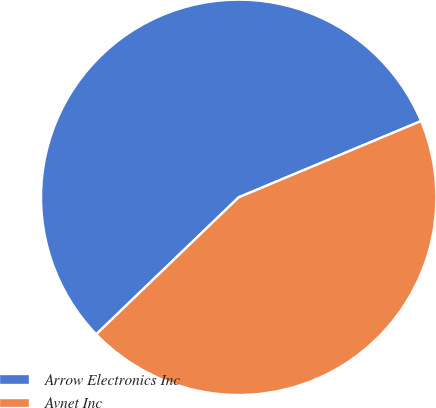Convert chart to OTSL. <chart><loc_0><loc_0><loc_500><loc_500><pie_chart><fcel>Arrow Electronics Inc<fcel>Avnet Inc<nl><fcel>55.88%<fcel>44.12%<nl></chart> 